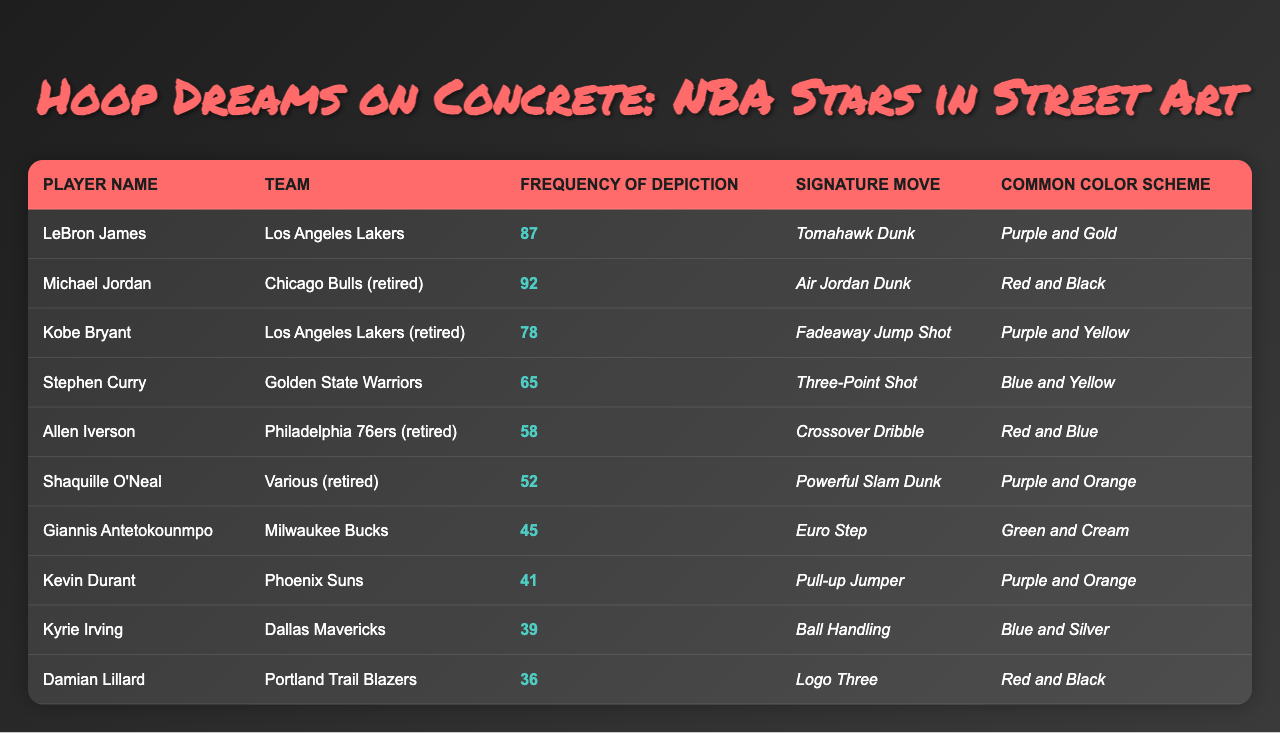What is the most frequently depicted NBA player in street art? By looking at the "Frequency of Depiction" column, Michael Jordan has the highest value of 92, making him the most frequently depicted player.
Answer: Michael Jordan How many times is LeBron James depicted in street art? The "Frequency of Depiction" for LeBron James is listed as 87.
Answer: 87 Which player has the least frequency of depiction and what is the value? By scanning the "Frequency of Depiction" column, Damian Lillard has the least frequency at 36.
Answer: Damian Lillard, 36 What is the common color scheme for Allen Iverson? In the table, the "Common Color Scheme" for Allen Iverson is noted as "Red and Blue."
Answer: Red and Blue Which two players have the same team color scheme of purple? The table shows that both LeBron James and Kobe Bryant have color schemes of Purple (LeBron with Purple and Gold and Kobe with Purple and Yellow).
Answer: LeBron James and Kobe Bryant What is the total frequency of depiction for all players? Summing the values from the "Frequency of Depiction" column: 92 + 87 + 78 + 65 + 58 + 52 + 45 + 41 + 39 + 36 =  621.
Answer: 621 Is Giannis Antetokounmpo depicted more often than Kyrie Irving? Giannis has a frequency of 45, while Kyrie has 39, so Giannis is depicted more often.
Answer: Yes What signature move is associated with Shaquille O'Neal? The "Signature Move" for Shaquille O'Neal is indicated as "Powerful Slam Dunk."
Answer: Powerful Slam Dunk How many players have a frequency of depiction greater than 50? Scanning for frequencies greater than 50, we identify LeBron James, Michael Jordan, Kobe Bryant, Stephen Curry, Allen Iverson, and Shaquille O'Neal, totaling 6 players.
Answer: 6 If you consider only the players from Los Angeles, how many times are they depicted in total? Adding the frequencies for players from Los Angeles: LeBron James (87) + Kobe Bryant (78) = 165.
Answer: 165 